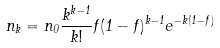Convert formula to latex. <formula><loc_0><loc_0><loc_500><loc_500>n _ { k } = n _ { 0 } \frac { k ^ { k - 1 } } { k ! } f ( 1 - f ) ^ { k - 1 } e ^ { - k ( 1 - f ) }</formula> 